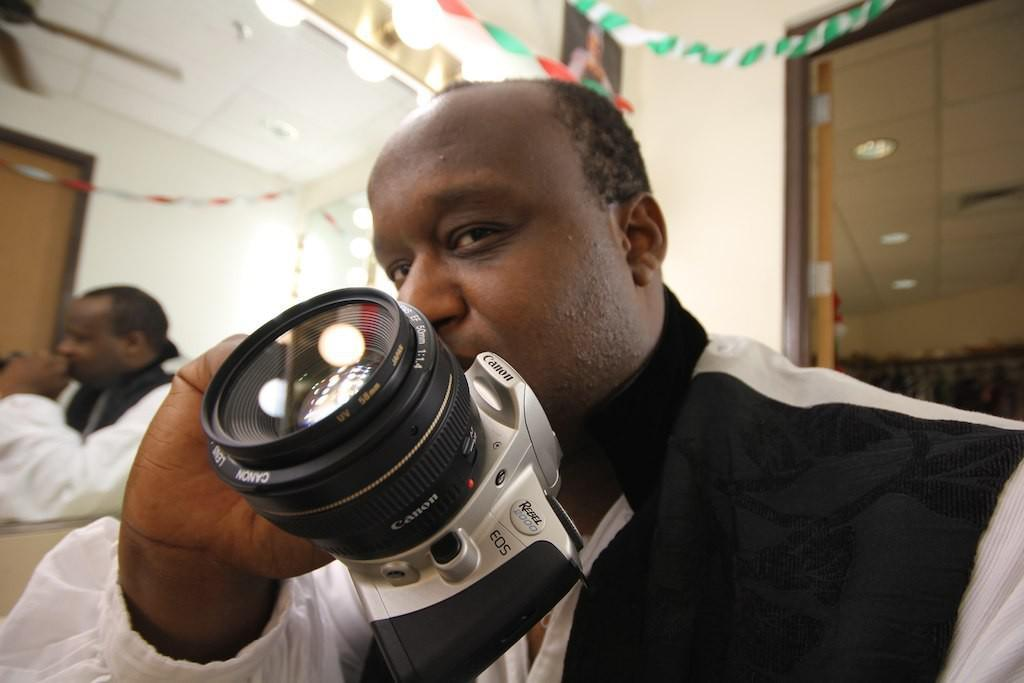What is the person in the image holding? The person in the image is holding a camera. Can you describe the color of the wall in the background? The wall in the background has a cream color. Who else is present in the image besides the person holding the camera? There is another person sitting beside the person holding the camera. What type of meat is being cooked by the stranger in the image? There is no stranger or meat present in the image. 